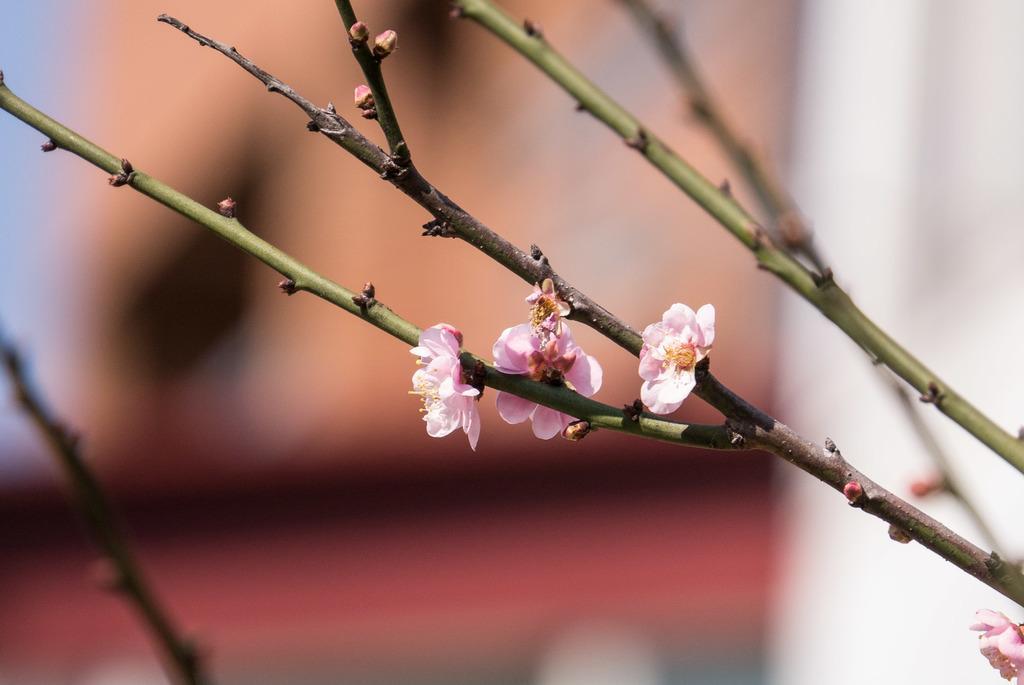In one or two sentences, can you explain what this image depicts? In this image there is a plant with flowers. 